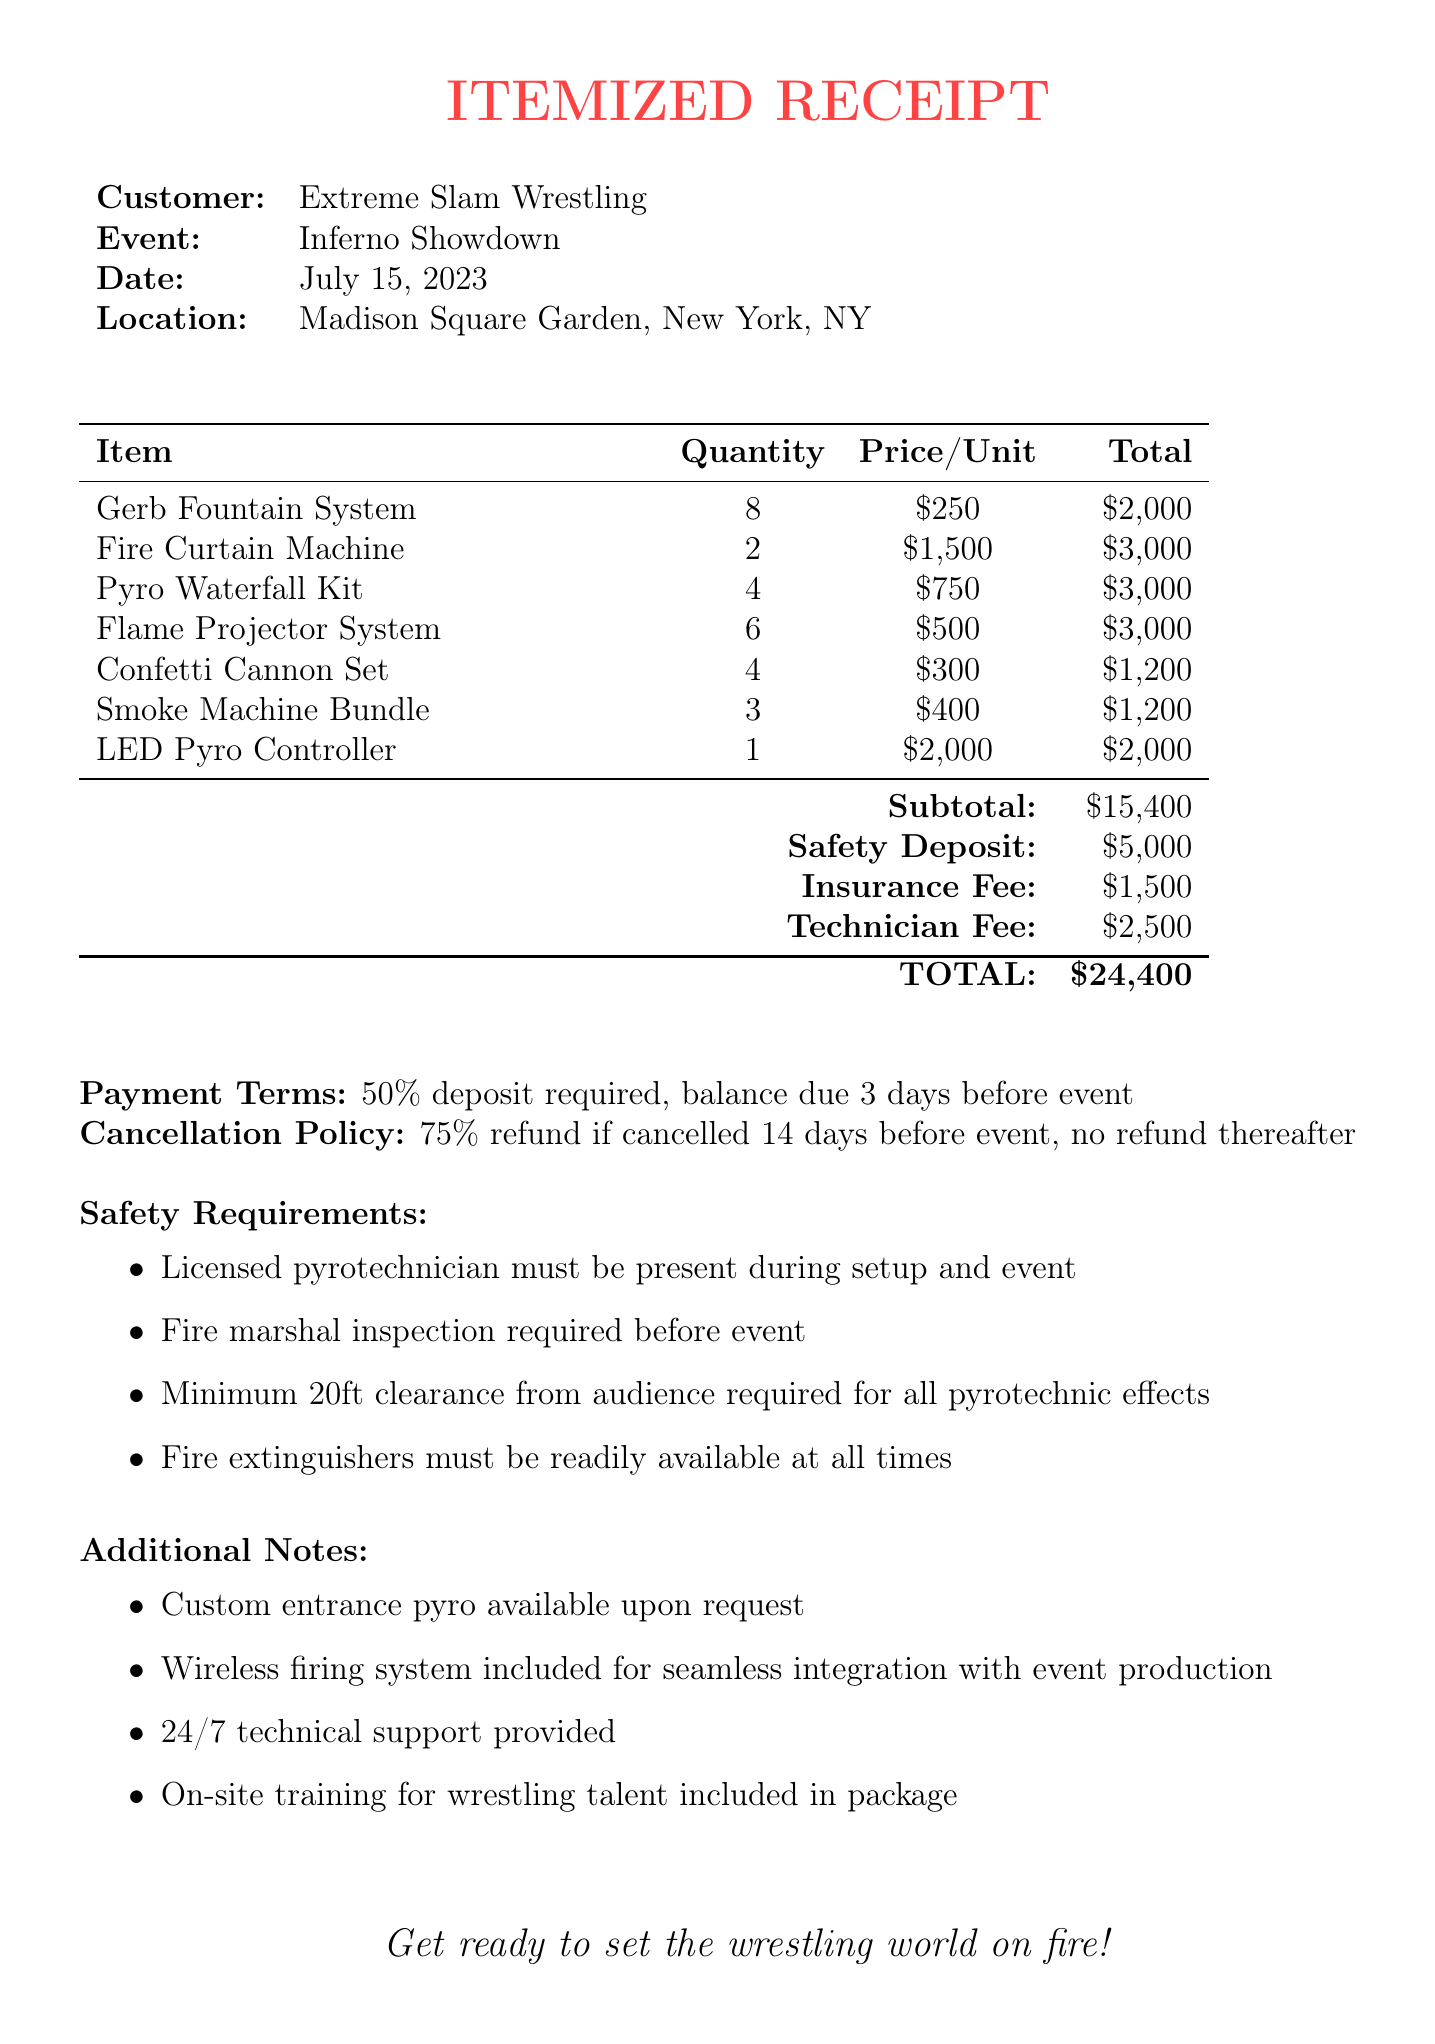what is the company name? The company name is listed at the top of the document.
Answer: Pyro Pro Wrestling FX who is the customer? The customer name is provided in the document.
Answer: Extreme Slam Wrestling what is the event name? The event name is mentioned in the receipt details.
Answer: Inferno Showdown what is the total amount due? The total amount due is clearly stated in the total section of the receipt.
Answer: $24,400 how many Gerb Fountain Systems were rented? The quantity of Gerb Fountain Systems is indicated in the itemized list.
Answer: 8 what is the subtotal before additional fees? The subtotal can be found in the summary section before additional costs are added.
Answer: $15,400 what is the safety deposit amount? The safety deposit amount is specified in the document.
Answer: $5,000 how much will the customer be refunded if they cancel 14 days before the event? The cancellation policy specifies the refund amount based on the timing of cancellation.
Answer: 75% how many technician fees are included? The technician fee amount is noted in the totals section of the receipt.
Answer: $2,500 what is one additional note mentioned? The additional notes section contains extra information regarding what is provided.
Answer: Custom entrance pyro available upon request 